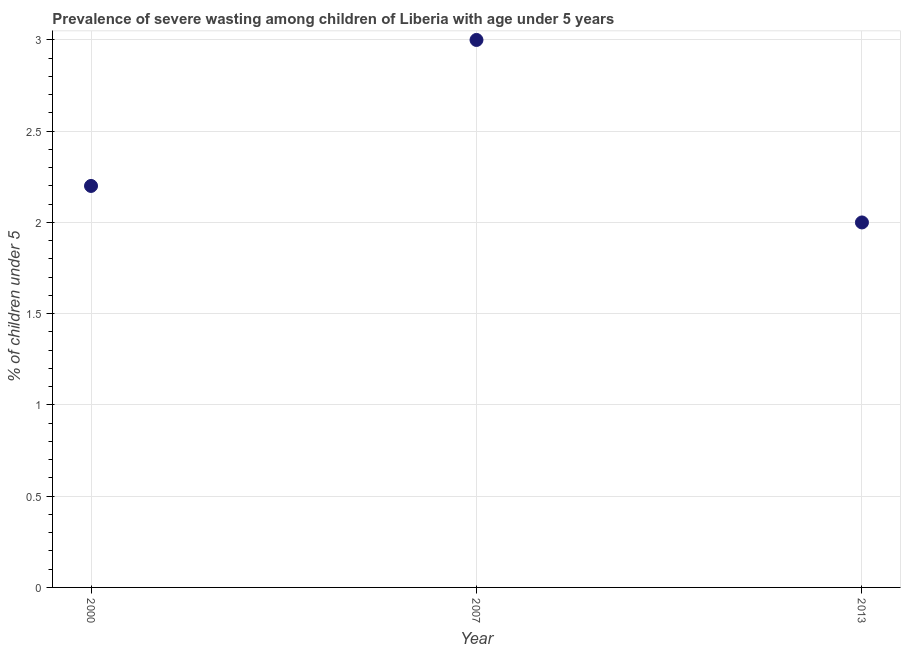What is the prevalence of severe wasting in 2000?
Your answer should be compact. 2.2. Across all years, what is the maximum prevalence of severe wasting?
Give a very brief answer. 3. Across all years, what is the minimum prevalence of severe wasting?
Provide a short and direct response. 2. In which year was the prevalence of severe wasting maximum?
Offer a terse response. 2007. In which year was the prevalence of severe wasting minimum?
Your answer should be very brief. 2013. What is the sum of the prevalence of severe wasting?
Make the answer very short. 7.2. What is the difference between the prevalence of severe wasting in 2000 and 2007?
Your answer should be very brief. -0.8. What is the average prevalence of severe wasting per year?
Provide a succinct answer. 2.4. What is the median prevalence of severe wasting?
Give a very brief answer. 2.2. What is the ratio of the prevalence of severe wasting in 2000 to that in 2007?
Provide a succinct answer. 0.73. Is the prevalence of severe wasting in 2000 less than that in 2013?
Ensure brevity in your answer.  No. Is the difference between the prevalence of severe wasting in 2007 and 2013 greater than the difference between any two years?
Ensure brevity in your answer.  Yes. What is the difference between the highest and the second highest prevalence of severe wasting?
Keep it short and to the point. 0.8. In how many years, is the prevalence of severe wasting greater than the average prevalence of severe wasting taken over all years?
Your answer should be compact. 1. How many dotlines are there?
Keep it short and to the point. 1. What is the difference between two consecutive major ticks on the Y-axis?
Offer a terse response. 0.5. What is the title of the graph?
Your response must be concise. Prevalence of severe wasting among children of Liberia with age under 5 years. What is the label or title of the X-axis?
Offer a terse response. Year. What is the label or title of the Y-axis?
Your response must be concise.  % of children under 5. What is the  % of children under 5 in 2000?
Your answer should be very brief. 2.2. What is the difference between the  % of children under 5 in 2000 and 2007?
Your answer should be compact. -0.8. What is the ratio of the  % of children under 5 in 2000 to that in 2007?
Keep it short and to the point. 0.73. What is the ratio of the  % of children under 5 in 2007 to that in 2013?
Offer a very short reply. 1.5. 